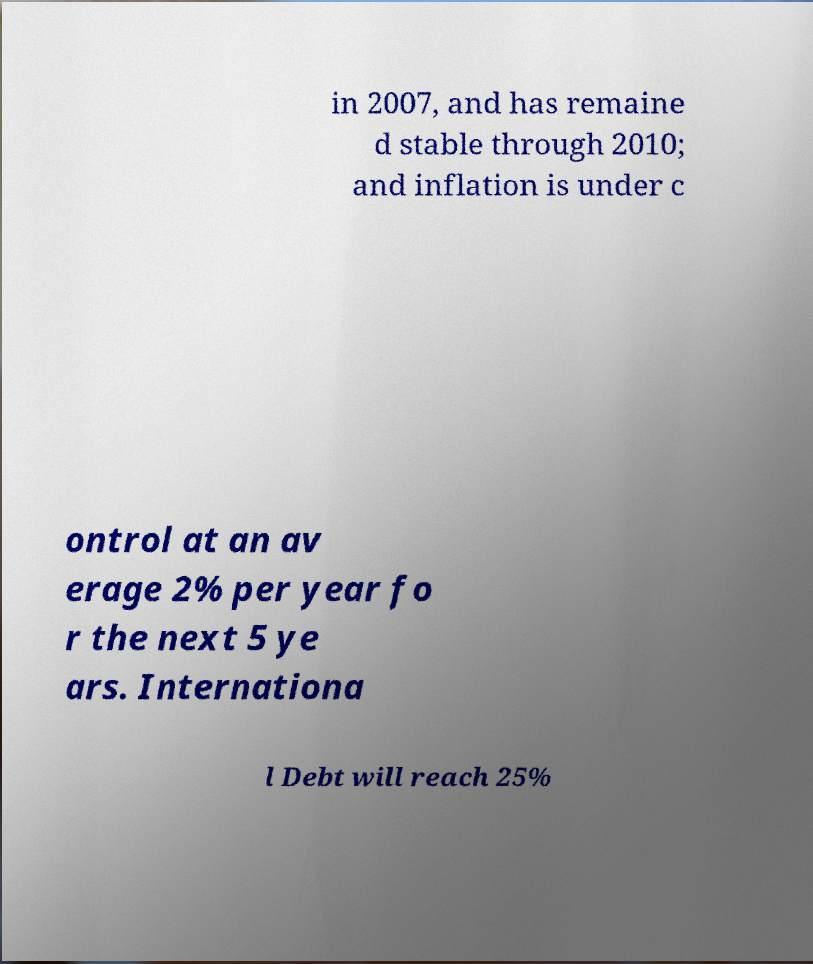Could you extract and type out the text from this image? in 2007, and has remaine d stable through 2010; and inflation is under c ontrol at an av erage 2% per year fo r the next 5 ye ars. Internationa l Debt will reach 25% 